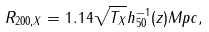Convert formula to latex. <formula><loc_0><loc_0><loc_500><loc_500>R _ { 2 0 0 , X } = 1 . 1 4 \sqrt { T _ { X } } h _ { 5 0 } ^ { - 1 } ( z ) M p c ,</formula> 